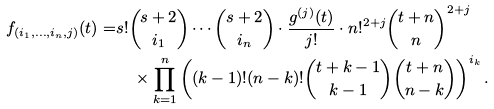Convert formula to latex. <formula><loc_0><loc_0><loc_500><loc_500>f _ { ( i _ { 1 } , \dots , i _ { n } , j ) } ( t ) = & s ! \binom { s + 2 } { i _ { 1 } } \cdots \binom { s + 2 } { i _ { n } } \cdot \frac { g ^ { ( j ) } ( t ) } { j ! } \cdot n ! ^ { 2 + j } \binom { t + n } { n } ^ { 2 + j } \\ & \quad \times \prod _ { k = 1 } ^ { n } \left ( ( k - 1 ) ! ( n - k ) ! \binom { t + k - 1 } { k - 1 } \binom { t + n } { n - k } \right ) ^ { i _ { k } } .</formula> 